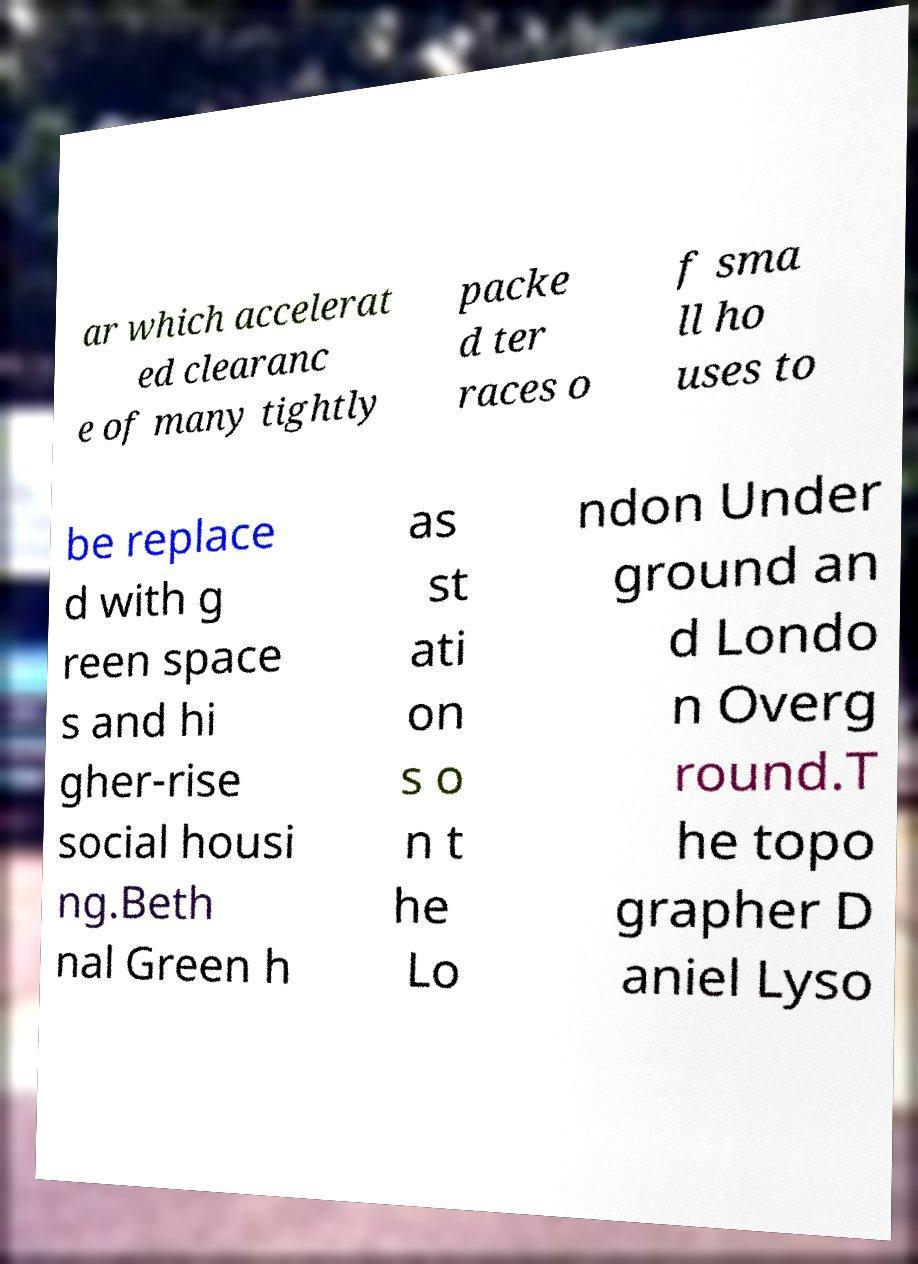Could you assist in decoding the text presented in this image and type it out clearly? ar which accelerat ed clearanc e of many tightly packe d ter races o f sma ll ho uses to be replace d with g reen space s and hi gher-rise social housi ng.Beth nal Green h as st ati on s o n t he Lo ndon Under ground an d Londo n Overg round.T he topo grapher D aniel Lyso 